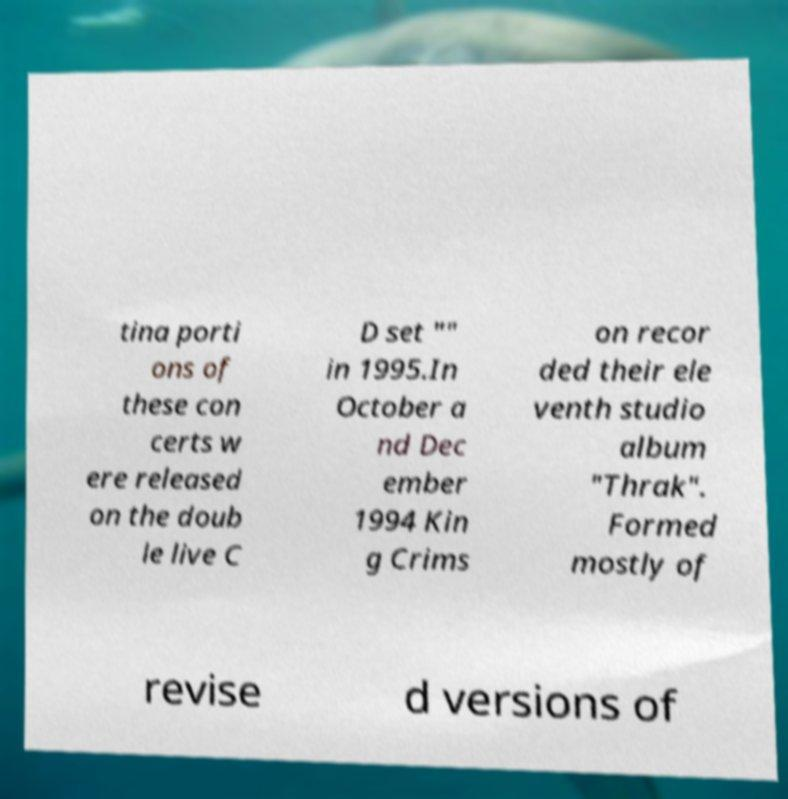Please identify and transcribe the text found in this image. tina porti ons of these con certs w ere released on the doub le live C D set "" in 1995.In October a nd Dec ember 1994 Kin g Crims on recor ded their ele venth studio album "Thrak". Formed mostly of revise d versions of 